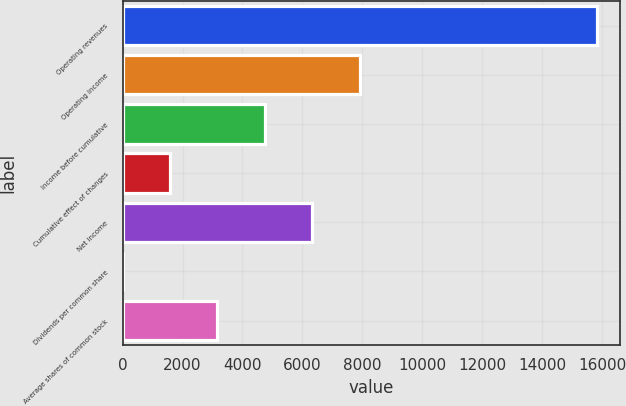Convert chart to OTSL. <chart><loc_0><loc_0><loc_500><loc_500><bar_chart><fcel>Operating revenues<fcel>Operating income<fcel>Income before cumulative<fcel>Cumulative effect of changes<fcel>Net income<fcel>Dividends per common share<fcel>Average shares of common stock<nl><fcel>15812<fcel>7906.46<fcel>4744.26<fcel>1582.06<fcel>6325.36<fcel>0.96<fcel>3163.16<nl></chart> 